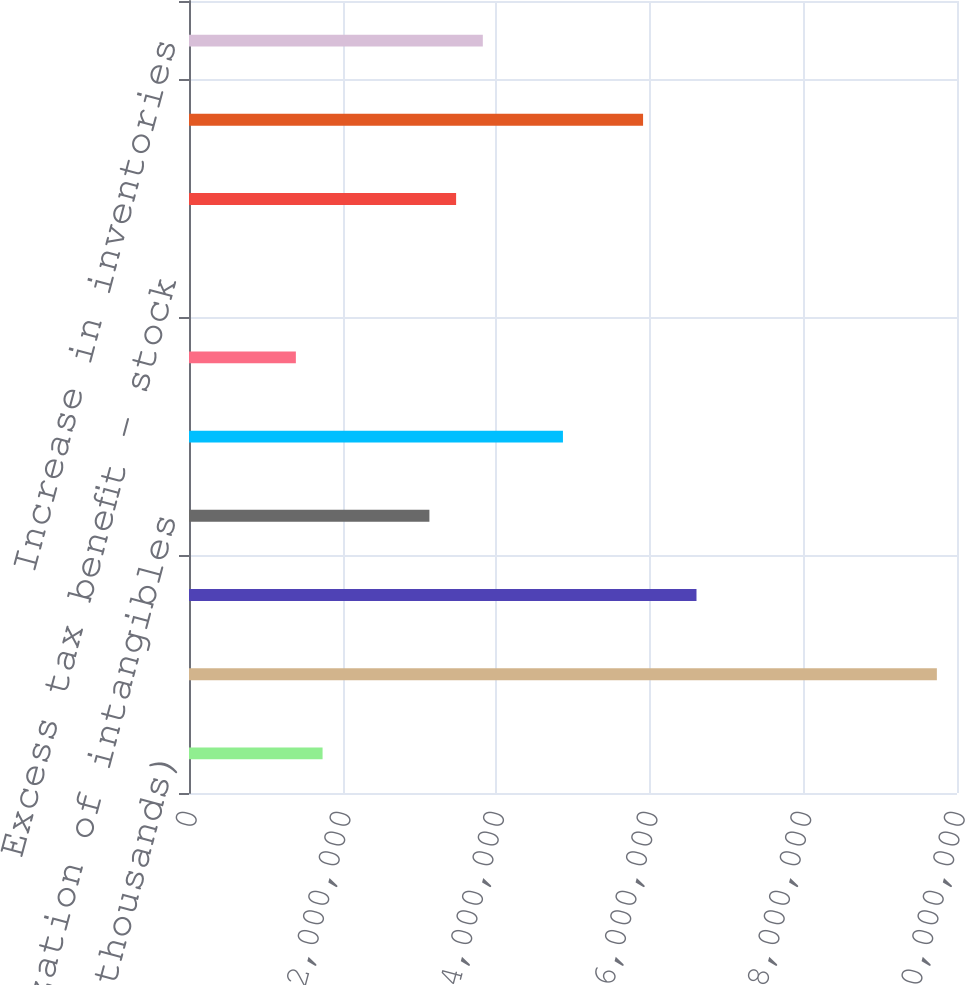Convert chart. <chart><loc_0><loc_0><loc_500><loc_500><bar_chart><fcel>(thousands)<fcel>Net income<fcel>Depreciation<fcel>Amortization of intangibles<fcel>Stock-based compensation<fcel>Other non-cash activity<fcel>Excess tax benefit - stock<fcel>Deferred income taxes<fcel>Decrease (increase) in<fcel>Increase in inventories<nl><fcel>1.73917e+06<fcel>9.7379e+06<fcel>6.60796e+06<fcel>3.13025e+06<fcel>4.86911e+06<fcel>1.3914e+06<fcel>317<fcel>3.47802e+06<fcel>5.91242e+06<fcel>3.8258e+06<nl></chart> 